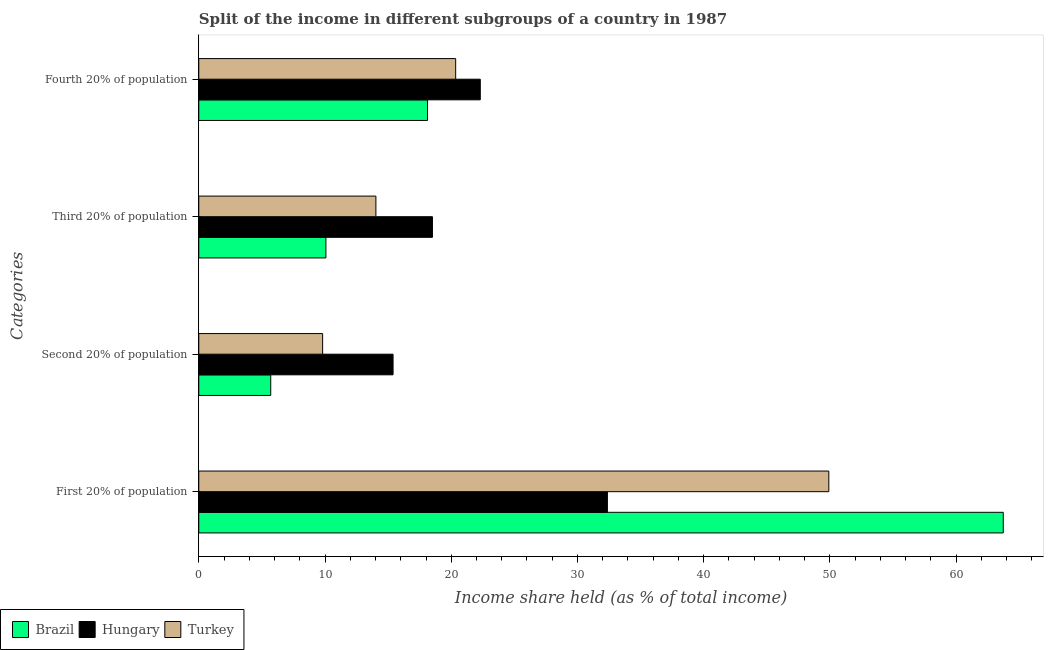How many bars are there on the 3rd tick from the top?
Your answer should be very brief. 3. How many bars are there on the 3rd tick from the bottom?
Make the answer very short. 3. What is the label of the 1st group of bars from the top?
Keep it short and to the point. Fourth 20% of population. What is the share of the income held by second 20% of the population in Hungary?
Give a very brief answer. 15.39. Across all countries, what is the maximum share of the income held by third 20% of the population?
Provide a succinct answer. 18.51. Across all countries, what is the minimum share of the income held by first 20% of the population?
Your answer should be compact. 32.37. In which country was the share of the income held by second 20% of the population maximum?
Keep it short and to the point. Hungary. What is the total share of the income held by first 20% of the population in the graph?
Offer a very short reply. 146.01. What is the difference between the share of the income held by second 20% of the population in Hungary and that in Brazil?
Provide a succinct answer. 9.69. What is the difference between the share of the income held by second 20% of the population in Hungary and the share of the income held by first 20% of the population in Turkey?
Your answer should be compact. -34.52. What is the average share of the income held by fourth 20% of the population per country?
Offer a terse response. 20.26. What is the difference between the share of the income held by second 20% of the population and share of the income held by fourth 20% of the population in Hungary?
Provide a succinct answer. -6.91. What is the ratio of the share of the income held by second 20% of the population in Hungary to that in Brazil?
Provide a succinct answer. 2.7. Is the share of the income held by fourth 20% of the population in Brazil less than that in Hungary?
Your answer should be compact. Yes. What is the difference between the highest and the second highest share of the income held by first 20% of the population?
Keep it short and to the point. 13.82. What is the difference between the highest and the lowest share of the income held by second 20% of the population?
Provide a short and direct response. 9.69. Is it the case that in every country, the sum of the share of the income held by third 20% of the population and share of the income held by fourth 20% of the population is greater than the sum of share of the income held by first 20% of the population and share of the income held by second 20% of the population?
Give a very brief answer. No. What does the 2nd bar from the top in Fourth 20% of population represents?
Keep it short and to the point. Hungary. How many bars are there?
Keep it short and to the point. 12. How many countries are there in the graph?
Your response must be concise. 3. Are the values on the major ticks of X-axis written in scientific E-notation?
Your answer should be very brief. No. Does the graph contain grids?
Give a very brief answer. No. Where does the legend appear in the graph?
Make the answer very short. Bottom left. What is the title of the graph?
Give a very brief answer. Split of the income in different subgroups of a country in 1987. What is the label or title of the X-axis?
Give a very brief answer. Income share held (as % of total income). What is the label or title of the Y-axis?
Your answer should be very brief. Categories. What is the Income share held (as % of total income) of Brazil in First 20% of population?
Keep it short and to the point. 63.73. What is the Income share held (as % of total income) in Hungary in First 20% of population?
Offer a very short reply. 32.37. What is the Income share held (as % of total income) in Turkey in First 20% of population?
Provide a short and direct response. 49.91. What is the Income share held (as % of total income) of Brazil in Second 20% of population?
Your answer should be very brief. 5.7. What is the Income share held (as % of total income) in Hungary in Second 20% of population?
Provide a short and direct response. 15.39. What is the Income share held (as % of total income) of Turkey in Second 20% of population?
Provide a short and direct response. 9.81. What is the Income share held (as % of total income) of Brazil in Third 20% of population?
Your response must be concise. 10.07. What is the Income share held (as % of total income) of Hungary in Third 20% of population?
Give a very brief answer. 18.51. What is the Income share held (as % of total income) in Turkey in Third 20% of population?
Give a very brief answer. 14.03. What is the Income share held (as % of total income) of Brazil in Fourth 20% of population?
Provide a short and direct response. 18.12. What is the Income share held (as % of total income) of Hungary in Fourth 20% of population?
Offer a terse response. 22.3. What is the Income share held (as % of total income) of Turkey in Fourth 20% of population?
Keep it short and to the point. 20.35. Across all Categories, what is the maximum Income share held (as % of total income) of Brazil?
Provide a short and direct response. 63.73. Across all Categories, what is the maximum Income share held (as % of total income) in Hungary?
Offer a terse response. 32.37. Across all Categories, what is the maximum Income share held (as % of total income) of Turkey?
Provide a short and direct response. 49.91. Across all Categories, what is the minimum Income share held (as % of total income) in Brazil?
Make the answer very short. 5.7. Across all Categories, what is the minimum Income share held (as % of total income) in Hungary?
Give a very brief answer. 15.39. Across all Categories, what is the minimum Income share held (as % of total income) of Turkey?
Keep it short and to the point. 9.81. What is the total Income share held (as % of total income) of Brazil in the graph?
Keep it short and to the point. 97.62. What is the total Income share held (as % of total income) in Hungary in the graph?
Ensure brevity in your answer.  88.57. What is the total Income share held (as % of total income) of Turkey in the graph?
Your response must be concise. 94.1. What is the difference between the Income share held (as % of total income) in Brazil in First 20% of population and that in Second 20% of population?
Offer a terse response. 58.03. What is the difference between the Income share held (as % of total income) of Hungary in First 20% of population and that in Second 20% of population?
Offer a terse response. 16.98. What is the difference between the Income share held (as % of total income) of Turkey in First 20% of population and that in Second 20% of population?
Keep it short and to the point. 40.1. What is the difference between the Income share held (as % of total income) of Brazil in First 20% of population and that in Third 20% of population?
Keep it short and to the point. 53.66. What is the difference between the Income share held (as % of total income) in Hungary in First 20% of population and that in Third 20% of population?
Your answer should be compact. 13.86. What is the difference between the Income share held (as % of total income) of Turkey in First 20% of population and that in Third 20% of population?
Offer a very short reply. 35.88. What is the difference between the Income share held (as % of total income) in Brazil in First 20% of population and that in Fourth 20% of population?
Your response must be concise. 45.61. What is the difference between the Income share held (as % of total income) of Hungary in First 20% of population and that in Fourth 20% of population?
Your answer should be very brief. 10.07. What is the difference between the Income share held (as % of total income) of Turkey in First 20% of population and that in Fourth 20% of population?
Your answer should be very brief. 29.56. What is the difference between the Income share held (as % of total income) in Brazil in Second 20% of population and that in Third 20% of population?
Keep it short and to the point. -4.37. What is the difference between the Income share held (as % of total income) in Hungary in Second 20% of population and that in Third 20% of population?
Your answer should be compact. -3.12. What is the difference between the Income share held (as % of total income) in Turkey in Second 20% of population and that in Third 20% of population?
Your answer should be compact. -4.22. What is the difference between the Income share held (as % of total income) of Brazil in Second 20% of population and that in Fourth 20% of population?
Keep it short and to the point. -12.42. What is the difference between the Income share held (as % of total income) of Hungary in Second 20% of population and that in Fourth 20% of population?
Offer a terse response. -6.91. What is the difference between the Income share held (as % of total income) in Turkey in Second 20% of population and that in Fourth 20% of population?
Your answer should be very brief. -10.54. What is the difference between the Income share held (as % of total income) in Brazil in Third 20% of population and that in Fourth 20% of population?
Provide a succinct answer. -8.05. What is the difference between the Income share held (as % of total income) of Hungary in Third 20% of population and that in Fourth 20% of population?
Keep it short and to the point. -3.79. What is the difference between the Income share held (as % of total income) in Turkey in Third 20% of population and that in Fourth 20% of population?
Offer a terse response. -6.32. What is the difference between the Income share held (as % of total income) of Brazil in First 20% of population and the Income share held (as % of total income) of Hungary in Second 20% of population?
Offer a very short reply. 48.34. What is the difference between the Income share held (as % of total income) in Brazil in First 20% of population and the Income share held (as % of total income) in Turkey in Second 20% of population?
Your answer should be very brief. 53.92. What is the difference between the Income share held (as % of total income) in Hungary in First 20% of population and the Income share held (as % of total income) in Turkey in Second 20% of population?
Keep it short and to the point. 22.56. What is the difference between the Income share held (as % of total income) of Brazil in First 20% of population and the Income share held (as % of total income) of Hungary in Third 20% of population?
Provide a short and direct response. 45.22. What is the difference between the Income share held (as % of total income) in Brazil in First 20% of population and the Income share held (as % of total income) in Turkey in Third 20% of population?
Your answer should be compact. 49.7. What is the difference between the Income share held (as % of total income) of Hungary in First 20% of population and the Income share held (as % of total income) of Turkey in Third 20% of population?
Your response must be concise. 18.34. What is the difference between the Income share held (as % of total income) of Brazil in First 20% of population and the Income share held (as % of total income) of Hungary in Fourth 20% of population?
Provide a short and direct response. 41.43. What is the difference between the Income share held (as % of total income) of Brazil in First 20% of population and the Income share held (as % of total income) of Turkey in Fourth 20% of population?
Offer a very short reply. 43.38. What is the difference between the Income share held (as % of total income) of Hungary in First 20% of population and the Income share held (as % of total income) of Turkey in Fourth 20% of population?
Give a very brief answer. 12.02. What is the difference between the Income share held (as % of total income) in Brazil in Second 20% of population and the Income share held (as % of total income) in Hungary in Third 20% of population?
Give a very brief answer. -12.81. What is the difference between the Income share held (as % of total income) in Brazil in Second 20% of population and the Income share held (as % of total income) in Turkey in Third 20% of population?
Provide a succinct answer. -8.33. What is the difference between the Income share held (as % of total income) of Hungary in Second 20% of population and the Income share held (as % of total income) of Turkey in Third 20% of population?
Your response must be concise. 1.36. What is the difference between the Income share held (as % of total income) in Brazil in Second 20% of population and the Income share held (as % of total income) in Hungary in Fourth 20% of population?
Provide a succinct answer. -16.6. What is the difference between the Income share held (as % of total income) in Brazil in Second 20% of population and the Income share held (as % of total income) in Turkey in Fourth 20% of population?
Your answer should be compact. -14.65. What is the difference between the Income share held (as % of total income) of Hungary in Second 20% of population and the Income share held (as % of total income) of Turkey in Fourth 20% of population?
Offer a very short reply. -4.96. What is the difference between the Income share held (as % of total income) in Brazil in Third 20% of population and the Income share held (as % of total income) in Hungary in Fourth 20% of population?
Your response must be concise. -12.23. What is the difference between the Income share held (as % of total income) in Brazil in Third 20% of population and the Income share held (as % of total income) in Turkey in Fourth 20% of population?
Offer a terse response. -10.28. What is the difference between the Income share held (as % of total income) of Hungary in Third 20% of population and the Income share held (as % of total income) of Turkey in Fourth 20% of population?
Offer a terse response. -1.84. What is the average Income share held (as % of total income) in Brazil per Categories?
Offer a terse response. 24.41. What is the average Income share held (as % of total income) in Hungary per Categories?
Your answer should be compact. 22.14. What is the average Income share held (as % of total income) in Turkey per Categories?
Provide a succinct answer. 23.52. What is the difference between the Income share held (as % of total income) in Brazil and Income share held (as % of total income) in Hungary in First 20% of population?
Offer a very short reply. 31.36. What is the difference between the Income share held (as % of total income) of Brazil and Income share held (as % of total income) of Turkey in First 20% of population?
Give a very brief answer. 13.82. What is the difference between the Income share held (as % of total income) in Hungary and Income share held (as % of total income) in Turkey in First 20% of population?
Provide a succinct answer. -17.54. What is the difference between the Income share held (as % of total income) of Brazil and Income share held (as % of total income) of Hungary in Second 20% of population?
Ensure brevity in your answer.  -9.69. What is the difference between the Income share held (as % of total income) of Brazil and Income share held (as % of total income) of Turkey in Second 20% of population?
Offer a terse response. -4.11. What is the difference between the Income share held (as % of total income) of Hungary and Income share held (as % of total income) of Turkey in Second 20% of population?
Ensure brevity in your answer.  5.58. What is the difference between the Income share held (as % of total income) of Brazil and Income share held (as % of total income) of Hungary in Third 20% of population?
Provide a succinct answer. -8.44. What is the difference between the Income share held (as % of total income) of Brazil and Income share held (as % of total income) of Turkey in Third 20% of population?
Provide a succinct answer. -3.96. What is the difference between the Income share held (as % of total income) of Hungary and Income share held (as % of total income) of Turkey in Third 20% of population?
Make the answer very short. 4.48. What is the difference between the Income share held (as % of total income) in Brazil and Income share held (as % of total income) in Hungary in Fourth 20% of population?
Your response must be concise. -4.18. What is the difference between the Income share held (as % of total income) in Brazil and Income share held (as % of total income) in Turkey in Fourth 20% of population?
Your answer should be very brief. -2.23. What is the difference between the Income share held (as % of total income) in Hungary and Income share held (as % of total income) in Turkey in Fourth 20% of population?
Keep it short and to the point. 1.95. What is the ratio of the Income share held (as % of total income) of Brazil in First 20% of population to that in Second 20% of population?
Offer a very short reply. 11.18. What is the ratio of the Income share held (as % of total income) in Hungary in First 20% of population to that in Second 20% of population?
Provide a succinct answer. 2.1. What is the ratio of the Income share held (as % of total income) of Turkey in First 20% of population to that in Second 20% of population?
Provide a succinct answer. 5.09. What is the ratio of the Income share held (as % of total income) of Brazil in First 20% of population to that in Third 20% of population?
Provide a short and direct response. 6.33. What is the ratio of the Income share held (as % of total income) of Hungary in First 20% of population to that in Third 20% of population?
Your response must be concise. 1.75. What is the ratio of the Income share held (as % of total income) in Turkey in First 20% of population to that in Third 20% of population?
Keep it short and to the point. 3.56. What is the ratio of the Income share held (as % of total income) in Brazil in First 20% of population to that in Fourth 20% of population?
Provide a short and direct response. 3.52. What is the ratio of the Income share held (as % of total income) of Hungary in First 20% of population to that in Fourth 20% of population?
Provide a short and direct response. 1.45. What is the ratio of the Income share held (as % of total income) in Turkey in First 20% of population to that in Fourth 20% of population?
Provide a succinct answer. 2.45. What is the ratio of the Income share held (as % of total income) in Brazil in Second 20% of population to that in Third 20% of population?
Offer a very short reply. 0.57. What is the ratio of the Income share held (as % of total income) of Hungary in Second 20% of population to that in Third 20% of population?
Make the answer very short. 0.83. What is the ratio of the Income share held (as % of total income) in Turkey in Second 20% of population to that in Third 20% of population?
Give a very brief answer. 0.7. What is the ratio of the Income share held (as % of total income) of Brazil in Second 20% of population to that in Fourth 20% of population?
Provide a succinct answer. 0.31. What is the ratio of the Income share held (as % of total income) of Hungary in Second 20% of population to that in Fourth 20% of population?
Give a very brief answer. 0.69. What is the ratio of the Income share held (as % of total income) of Turkey in Second 20% of population to that in Fourth 20% of population?
Provide a short and direct response. 0.48. What is the ratio of the Income share held (as % of total income) of Brazil in Third 20% of population to that in Fourth 20% of population?
Your response must be concise. 0.56. What is the ratio of the Income share held (as % of total income) in Hungary in Third 20% of population to that in Fourth 20% of population?
Give a very brief answer. 0.83. What is the ratio of the Income share held (as % of total income) of Turkey in Third 20% of population to that in Fourth 20% of population?
Offer a terse response. 0.69. What is the difference between the highest and the second highest Income share held (as % of total income) of Brazil?
Your response must be concise. 45.61. What is the difference between the highest and the second highest Income share held (as % of total income) of Hungary?
Ensure brevity in your answer.  10.07. What is the difference between the highest and the second highest Income share held (as % of total income) in Turkey?
Make the answer very short. 29.56. What is the difference between the highest and the lowest Income share held (as % of total income) in Brazil?
Make the answer very short. 58.03. What is the difference between the highest and the lowest Income share held (as % of total income) in Hungary?
Offer a very short reply. 16.98. What is the difference between the highest and the lowest Income share held (as % of total income) in Turkey?
Give a very brief answer. 40.1. 